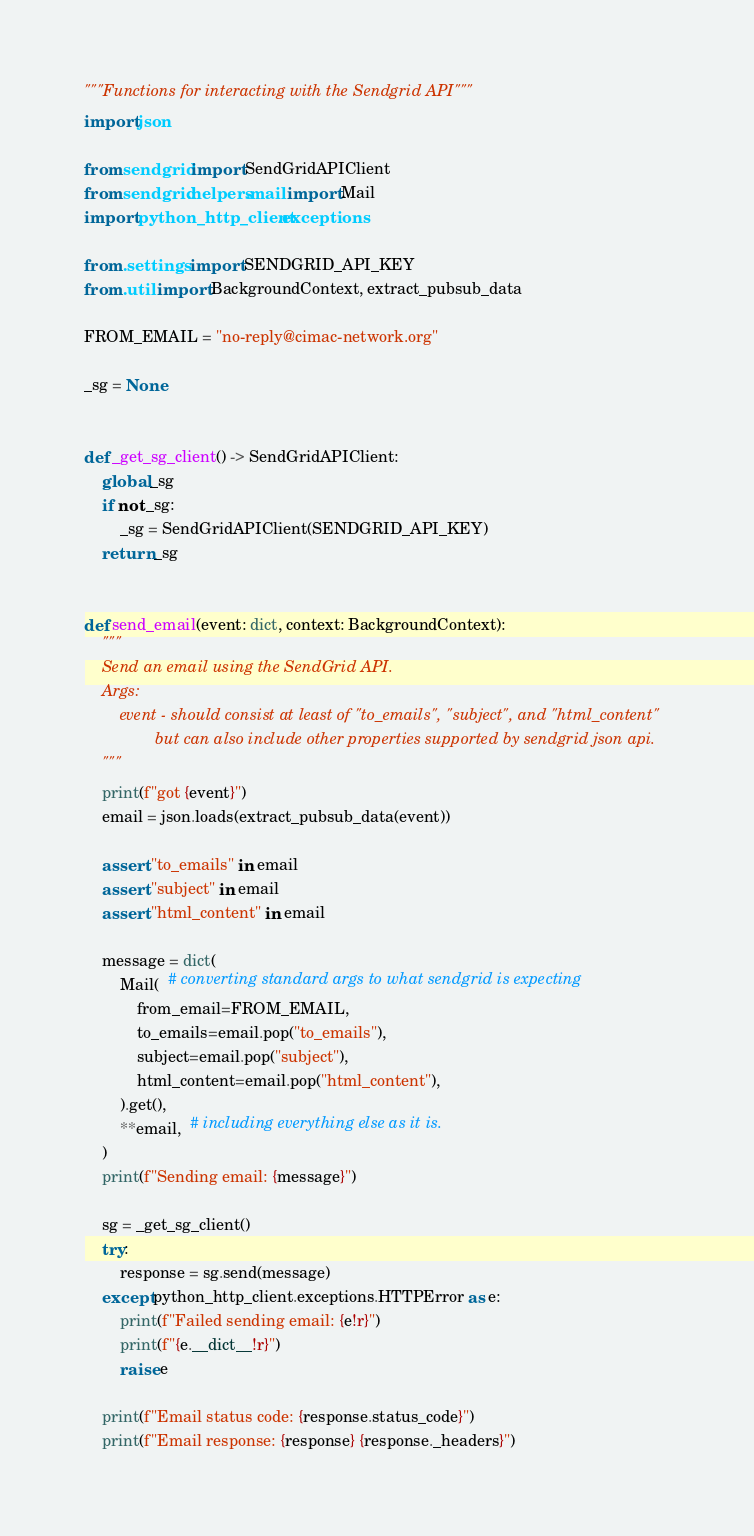Convert code to text. <code><loc_0><loc_0><loc_500><loc_500><_Python_>"""Functions for interacting with the Sendgrid API"""
import json

from sendgrid import SendGridAPIClient
from sendgrid.helpers.mail import Mail
import python_http_client.exceptions

from .settings import SENDGRID_API_KEY
from .util import BackgroundContext, extract_pubsub_data

FROM_EMAIL = "no-reply@cimac-network.org"

_sg = None


def _get_sg_client() -> SendGridAPIClient:
    global _sg
    if not _sg:
        _sg = SendGridAPIClient(SENDGRID_API_KEY)
    return _sg


def send_email(event: dict, context: BackgroundContext):
    """
    Send an email using the SendGrid API.
    Args:
        event - should consist at least of "to_emails", "subject", and "html_content"
                but can also include other properties supported by sendgrid json api.
    """
    print(f"got {event}")
    email = json.loads(extract_pubsub_data(event))

    assert "to_emails" in email
    assert "subject" in email
    assert "html_content" in email

    message = dict(
        Mail(  # converting standard args to what sendgrid is expecting
            from_email=FROM_EMAIL,
            to_emails=email.pop("to_emails"),
            subject=email.pop("subject"),
            html_content=email.pop("html_content"),
        ).get(),
        **email,  # including everything else as it is.
    )
    print(f"Sending email: {message}")

    sg = _get_sg_client()
    try:
        response = sg.send(message)
    except python_http_client.exceptions.HTTPError as e:
        print(f"Failed sending email: {e!r}")
        print(f"{e.__dict__!r}")
        raise e

    print(f"Email status code: {response.status_code}")
    print(f"Email response: {response} {response._headers}")
</code> 